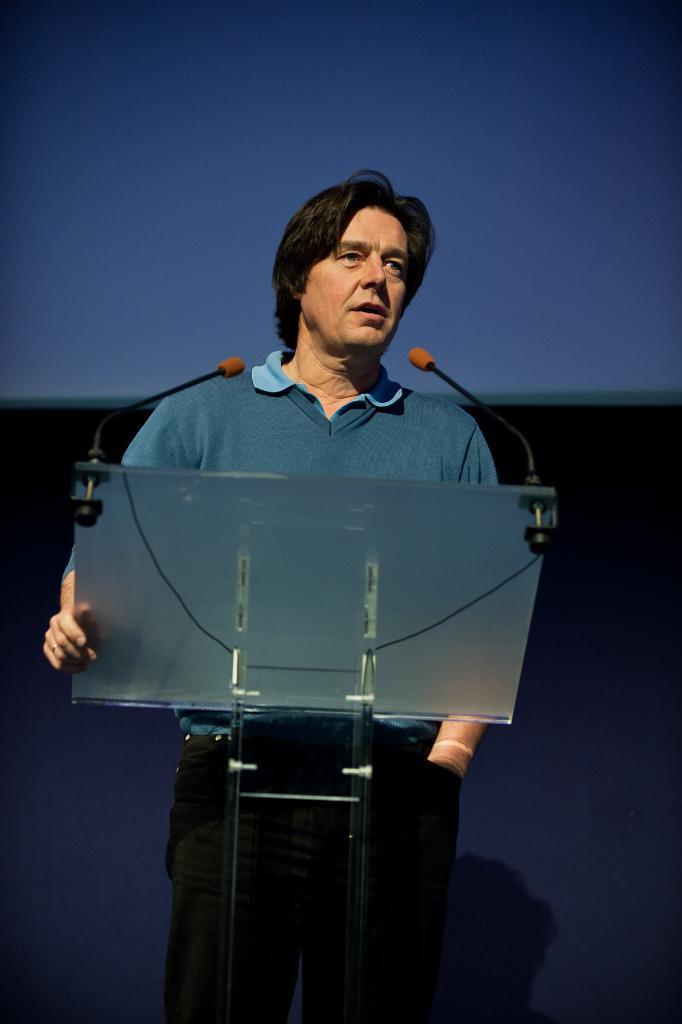How would you summarize this image in a sentence or two? In this image we can see a person standing near a podium and holding it. A person is speaking into the mics. There is an object at the top of the image. 